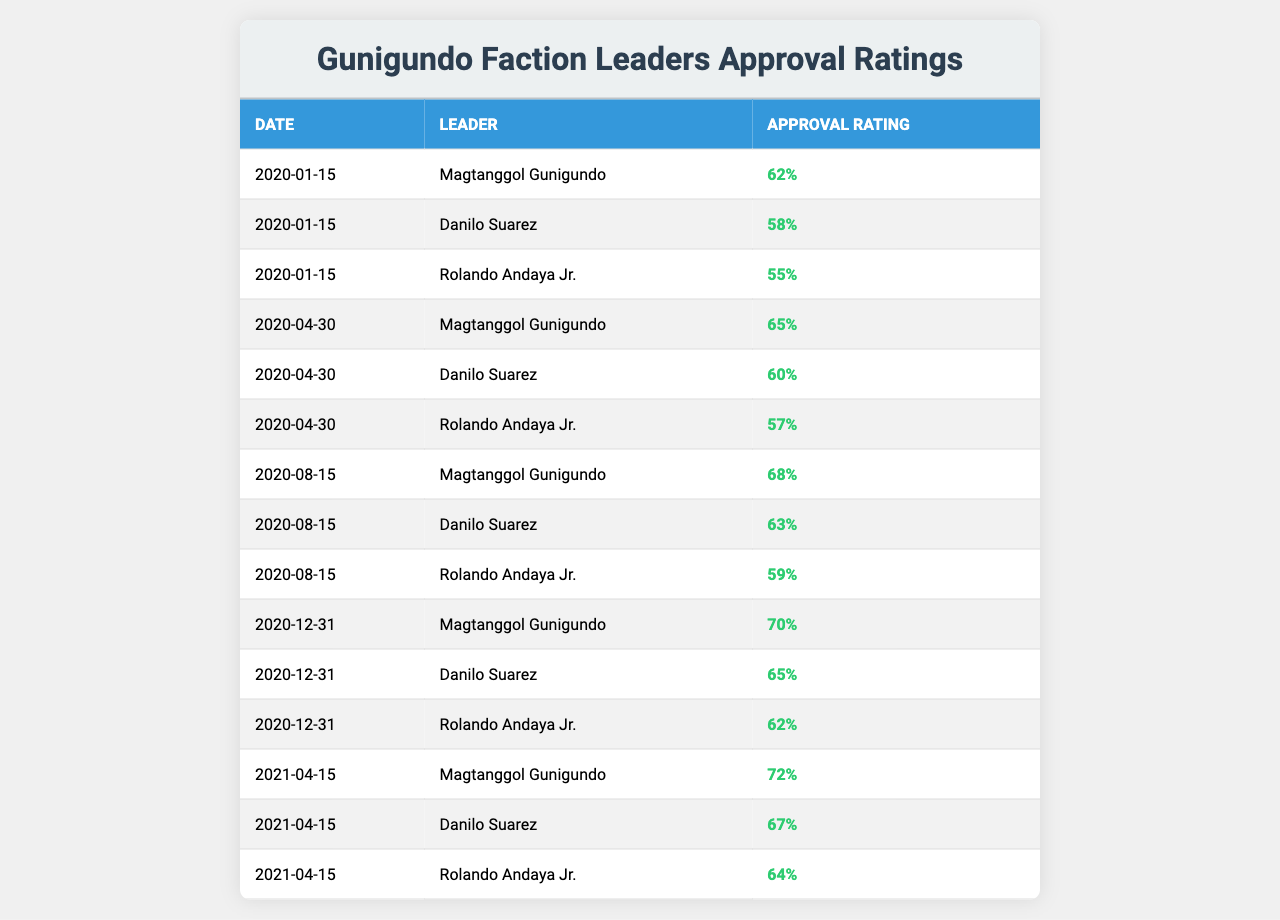What was Magtanggol Gunigundo's approval rating on January 15, 2020? Referring to the table, Magtanggol Gunigundo's approval rating on January 15, 2020, is listed as 62%.
Answer: 62% What is the highest approval rating recorded for Danilo Suarez? By examining the table, Danilo Suarez's highest approval rating is 67%, recorded on April 15, 2021.
Answer: 67% Which leader had a consistent increase in approval ratings throughout the observed dates? Looking at the table, Magtanggol Gunigundo shows a consistent increase in approval ratings: 62%, 65%, 68%, 70%, and then 72%.
Answer: Yes What was the average approval rating for Rolando Andaya Jr. across all dates? The approval ratings for Rolando Andaya Jr. are 55%, 57%, 59%, 62%, and 64%. Adding these gives 55 + 57 + 59 + 62 + 64 = 297. Dividing by the number of entries (5) gives an average of 297 / 5 = 59.4%.
Answer: 59.4% What was Magtanggol Gunigundo's approval rating on the last recorded date, December 31, 2020? The last recorded date, December 31, 2020, shows Magtanggol Gunigundo's approval rating as 70%.
Answer: 70% How much did Danilo Suarez's approval rating increase from April 30, 2020, to December 31, 2020? On April 30, 2020, Danilo Suarez's approval rating was 60%, and on December 31, 2020, it was 65%. The increase is calculated as 65 - 60 = 5%.
Answer: 5% Did Rolando Andaya Jr. ever have a higher approval rating than Danilo Suarez in the data provided? By comparing the values, there are instances where Rolando Andaya Jr.'s ratings match Danilo Suarez's but never exceed them. His highest rating was 64%, while Danilo Suarez's was 67%.
Answer: No What is the difference between Magtanggol Gunigundo's highest and lowest recorded approval ratings? The highest recorded rating for Magtanggol Gunigundo is 72% (on April 15, 2021) and the lowest is 62% (on January 15, 2020). The difference is 72 - 62 = 10%.
Answer: 10% Which date saw the highest overall approval rating for the Gunigundo faction leaders? Comparing all the dates, April 15, 2021, has the highest maximum approval rating, where Magtanggol Gunigundo reached 72%.
Answer: April 15, 2021 What trend can be observed in Magtanggol Gunigundo's approval ratings throughout 2020? Analyzing the data, Magtanggol Gunigundo's approval ratings consistently increased from 62% in January 2020 to 70% by December 2020, indicating a positive upward trend for that year.
Answer: Positive upward trend 